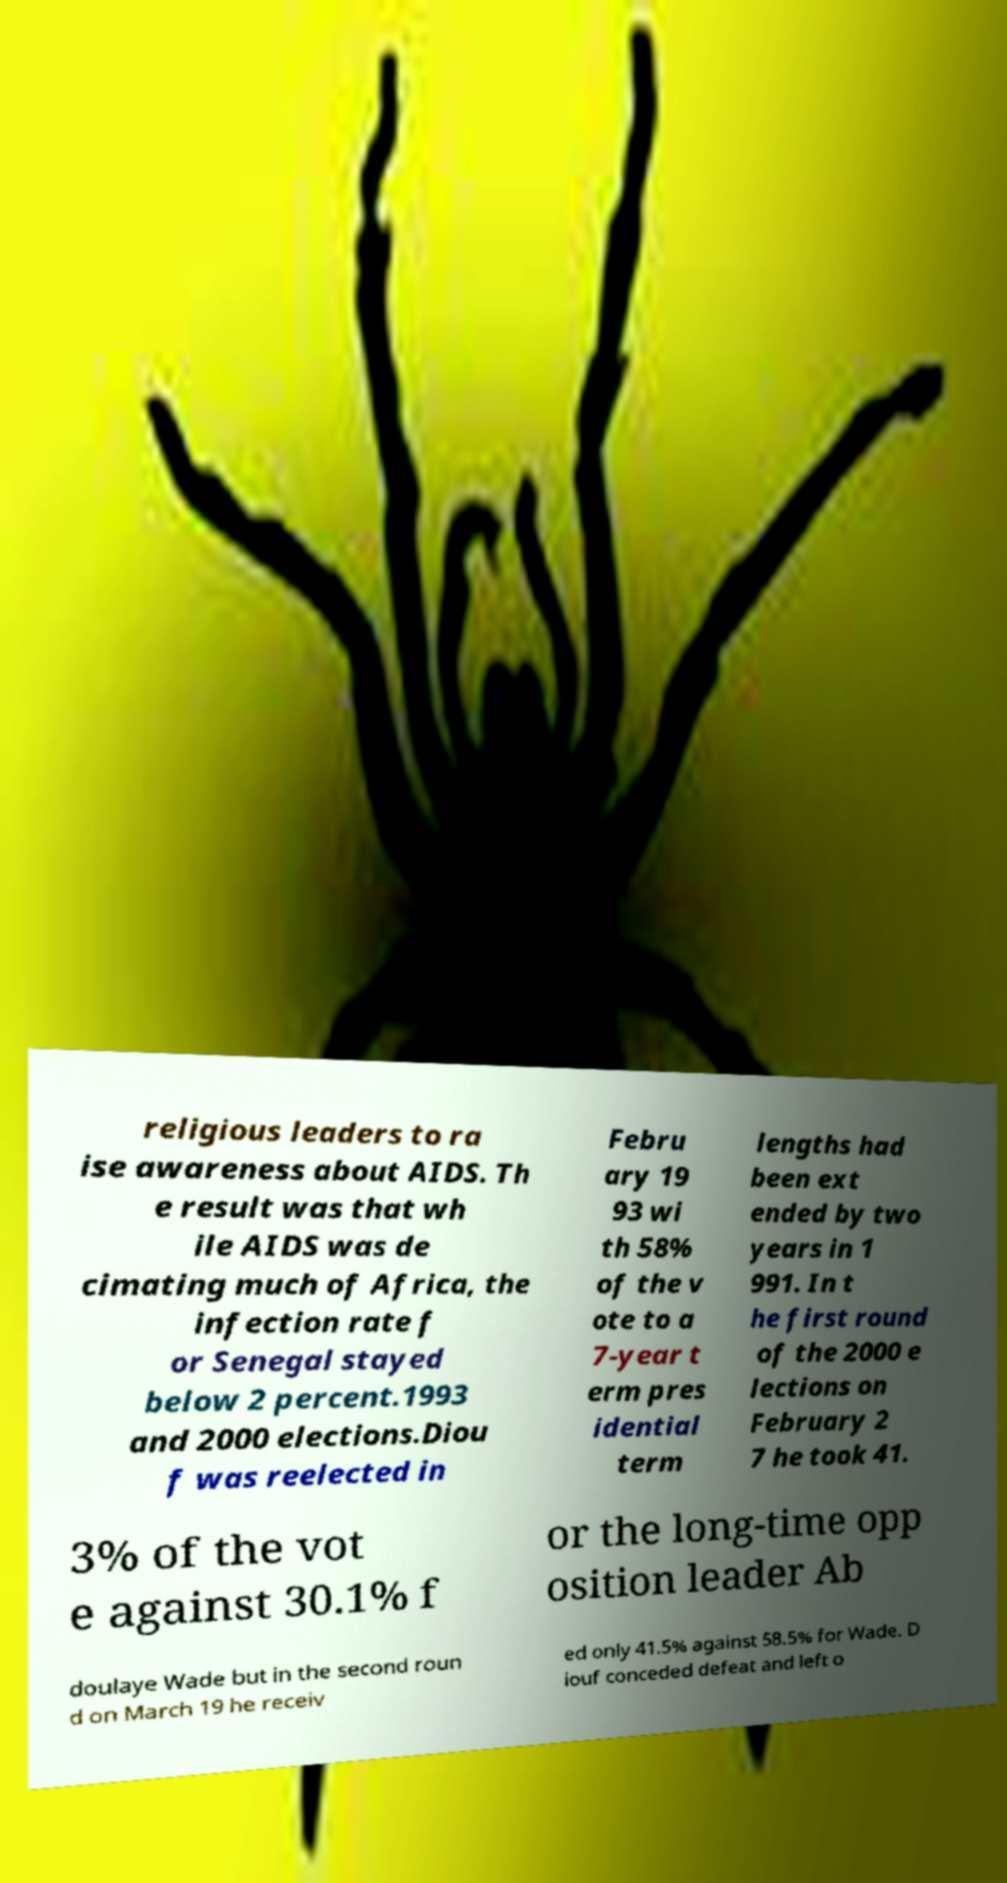Please identify and transcribe the text found in this image. religious leaders to ra ise awareness about AIDS. Th e result was that wh ile AIDS was de cimating much of Africa, the infection rate f or Senegal stayed below 2 percent.1993 and 2000 elections.Diou f was reelected in Febru ary 19 93 wi th 58% of the v ote to a 7-year t erm pres idential term lengths had been ext ended by two years in 1 991. In t he first round of the 2000 e lections on February 2 7 he took 41. 3% of the vot e against 30.1% f or the long-time opp osition leader Ab doulaye Wade but in the second roun d on March 19 he receiv ed only 41.5% against 58.5% for Wade. D iouf conceded defeat and left o 